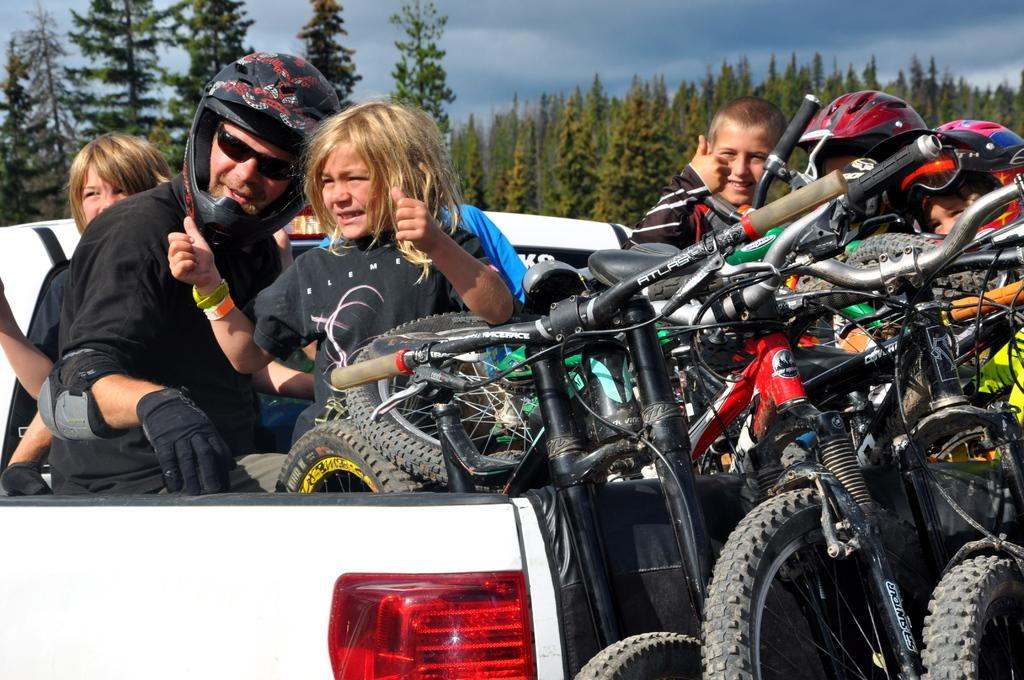What is the main subject of the image? The main subject of the image is a man. Can you describe the man's appearance? The man is wearing glasses and a helmet. Who else is present in the image? There are kids in the image. What type of vehicle can be seen in the image? There is a vehicle in the image. What other objects are visible in the image? There are trees and bicycles in the image. What can be seen in the sky in the image? The sky is visible in the image, and there are clouds in the sky. What type of advertisement can be seen on the trees in the image? There is no advertisement present on the trees in the image. What type of wilderness can be seen in the background of the image? There is no wilderness visible in the image; it features a man, kids, a vehicle, trees, and bicycles. 